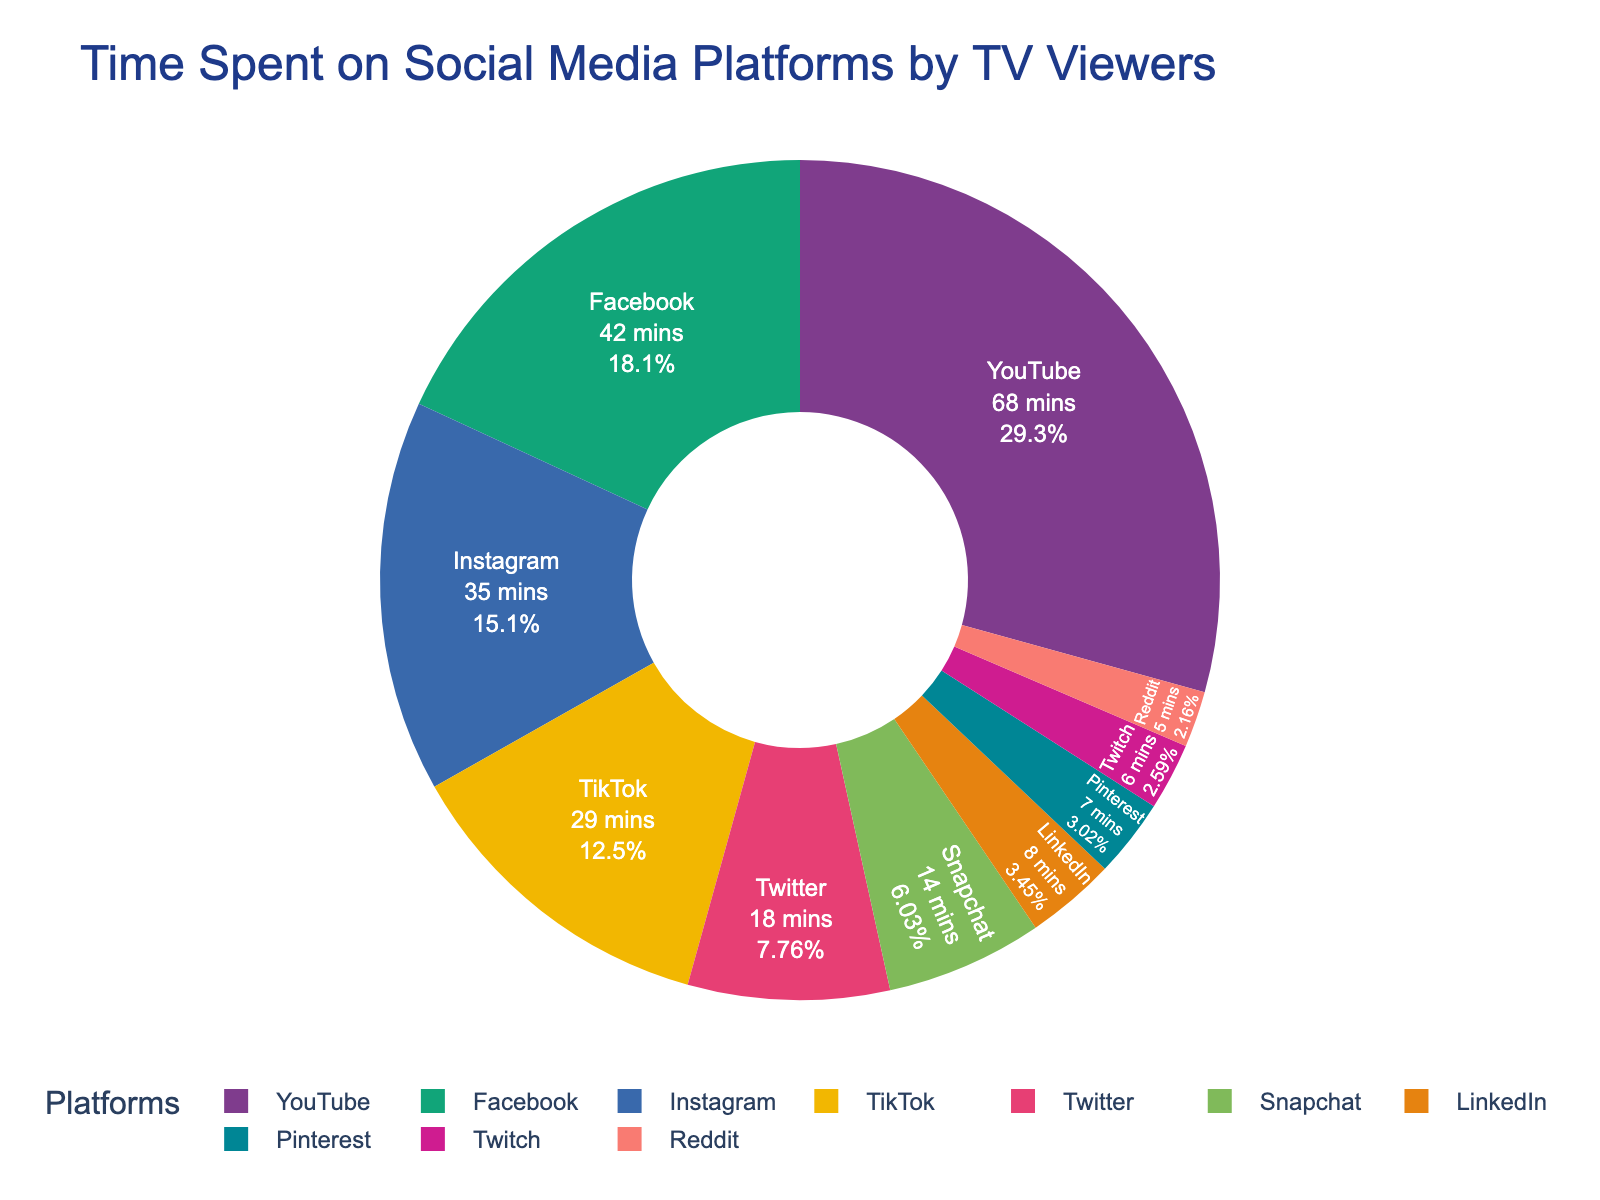What's the total time spent on YouTube, Facebook, and Instagram combined? Add the minutes spent on each of these platforms: YouTube (68), Facebook (42), and Instagram (35). The total is 68 + 42 + 35 = 145 minutes.
Answer: 145 minutes Which platform do TV viewers spend the most time on? By observing the chart, YouTube has the largest segment, indicating that TV viewers spend the most time on YouTube, which is 68 minutes.
Answer: YouTube How much more time is spent on YouTube than TikTok? Subtract the minutes spent on TikTok (29) from the minutes spent on YouTube (68). The difference is 68 - 29 = 39 minutes.
Answer: 39 minutes What percentage of time do TV viewers spend on LinkedIn, Pinterest, Twitch, and Reddit combined? Add the minutes spent on each platform: LinkedIn (8), Pinterest (7), Twitch (6), and Reddit (5). The total is 8 + 7 + 6 + 5 = 26 minutes. To find the percentage, divide this total by the sum of time spent on all platforms and multiply by 100. The total time spent on all platforms is 232 minutes, so the percentage is (26 / 232) * 100 = 11.21%.
Answer: 11.21% Which platform has the smallest time spent by TV viewers? By observing the chart, Reddit has the smallest segment, indicating the least time spent on it, which is 5 minutes.
Answer: Reddit Is the time spent on Instagram greater than the time spent on Snapchat and LinkedIn combined? Add the minutes spent on Snapchat (14) and LinkedIn (8), which is 14 + 8 = 22 minutes. Compare with the time spent on Instagram (35). Since 35 > 22, the answer is yes.
Answer: Yes Compare the time spent on Facebook and Twitter. Which one is higher and by how much? Compare the minutes spent: Facebook (42) and Twitter (18). Facebook has higher time spent. The difference is 42 - 18 = 24 minutes.
Answer: Facebook by 24 minutes What fraction of total time is spent on Pinterest? The total time is 232 minutes. The time spent on Pinterest is 7 minutes. The fraction is 7/232, which simplifies to approximately 1/33 (or roughly 0.030).
Answer: 1/33 How many more minutes are spent on Instagram than on Twitch? Subtract the minutes spent on Twitch (6) from the minutes spent on Instagram (35). The difference is 35 - 6 = 29 minutes.
Answer: 29 minutes What is the average time spent on the platforms? Sum up the total time spent on all platforms, which is 232 minutes, and divide by the number of platforms, which is 10. The average is 232 / 10 = 23.2 minutes.
Answer: 23.2 minutes 